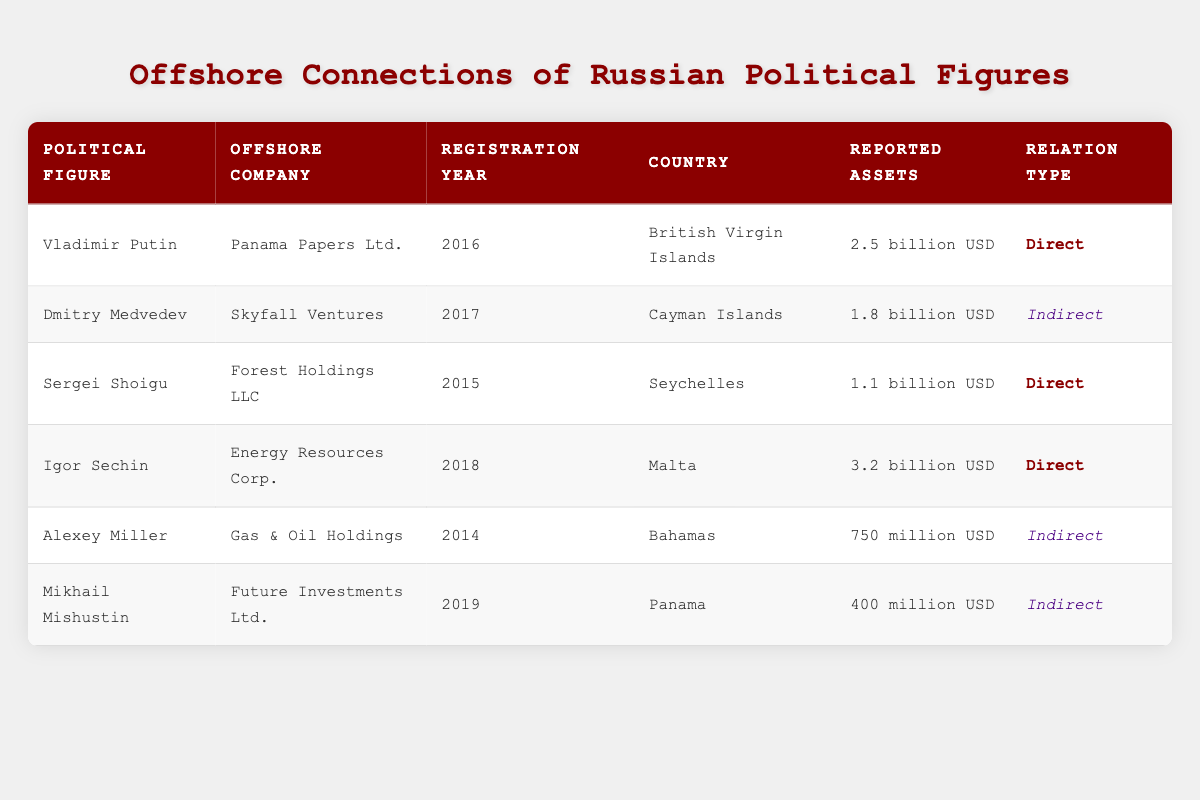What is the reported asset value of Igor Sechin's offshore company? Igor Sechin's offshore company, Energy Resources Corp., has reported assets of 3.2 billion USD. This value is directly listed in the table under the 'Reported Assets' column for Igor Sechin.
Answer: 3.2 billion USD Which offshore company is associated with Dmitry Medvedev and what year was it registered? The offshore company associated with Dmitry Medvedev is Skyfall Ventures, which was registered in 2017. This information can be found in the corresponding row for Dmitry Medvedev in the table.
Answer: Skyfall Ventures, 2017 How many political figures have a direct relation to their offshore companies? A total of 3 political figures have a direct relation to their offshore companies. This can be determined by checking the 'Relation Type' column for 'Direct' and counting the corresponding entries (Vladimir Putin, Sergei Shoigu, Igor Sechin).
Answer: 3 What is the combined reported asset value of the offshore companies associated with each political figure? The combined reported assets are calculated by summing the values: 2.5 billion + 1.8 billion + 1.1 billion + 3.2 billion + 750 million + 400 million = 11.8 billion USD. This takes into account all the reported assets for each political figure’s offshore company.
Answer: 11.8 billion USD Is it true that Alexey Miller's offshore company is registered in the Bahamas? Yes, it is true. The table shows that Alexey Miller's offshore company, Gas & Oil Holdings, is registered in the Bahamas, as listed in the 'Country' column for his row.
Answer: Yes What is the total number of offshore companies registered after the year 2016? There are 3 offshore companies registered after 2016. This can be verified by examining the 'Registration Year' column and counting the entries for 2017, 2018, and 2019 (Dmitry Medvedev, Igor Sechin, and Mikhail Mishustin).
Answer: 3 Which political figure has the lowest reported assets and what is that value? The political figure with the lowest reported assets is Mikhail Mishustin, whose offshore company, Future Investments Ltd., has reported assets of 400 million USD. This is indicated in the 'Reported Assets' column for Mikhail Mishustin.
Answer: 400 million USD Are there any political figures associated with offshore companies in the Cayman Islands? Yes, there is one political figure associated with an offshore company in the Cayman Islands, which is Dmitry Medvedev with his company Skyfall Ventures. This is shown in the 'Country' column for his row.
Answer: Yes 